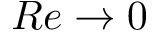<formula> <loc_0><loc_0><loc_500><loc_500>R e \to 0</formula> 